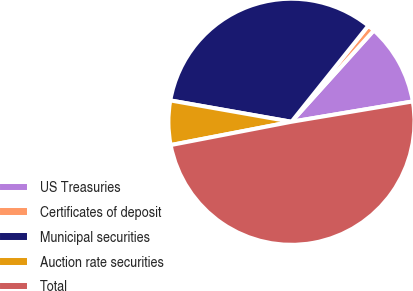<chart> <loc_0><loc_0><loc_500><loc_500><pie_chart><fcel>US Treasuries<fcel>Certificates of deposit<fcel>Municipal securities<fcel>Auction rate securities<fcel>Total<nl><fcel>10.68%<fcel>0.94%<fcel>32.96%<fcel>5.81%<fcel>49.61%<nl></chart> 